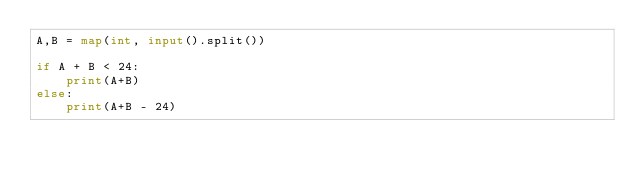Convert code to text. <code><loc_0><loc_0><loc_500><loc_500><_Python_>A,B = map(int, input().split())

if A + B < 24:
    print(A+B)
else:
    print(A+B - 24)</code> 